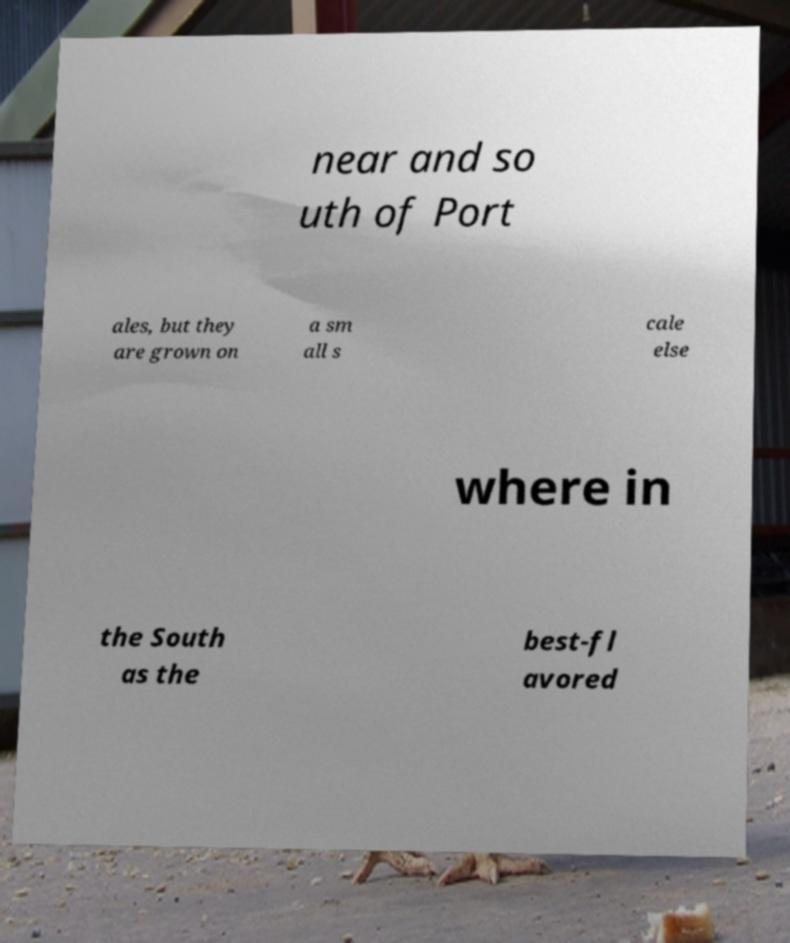What messages or text are displayed in this image? I need them in a readable, typed format. near and so uth of Port ales, but they are grown on a sm all s cale else where in the South as the best-fl avored 